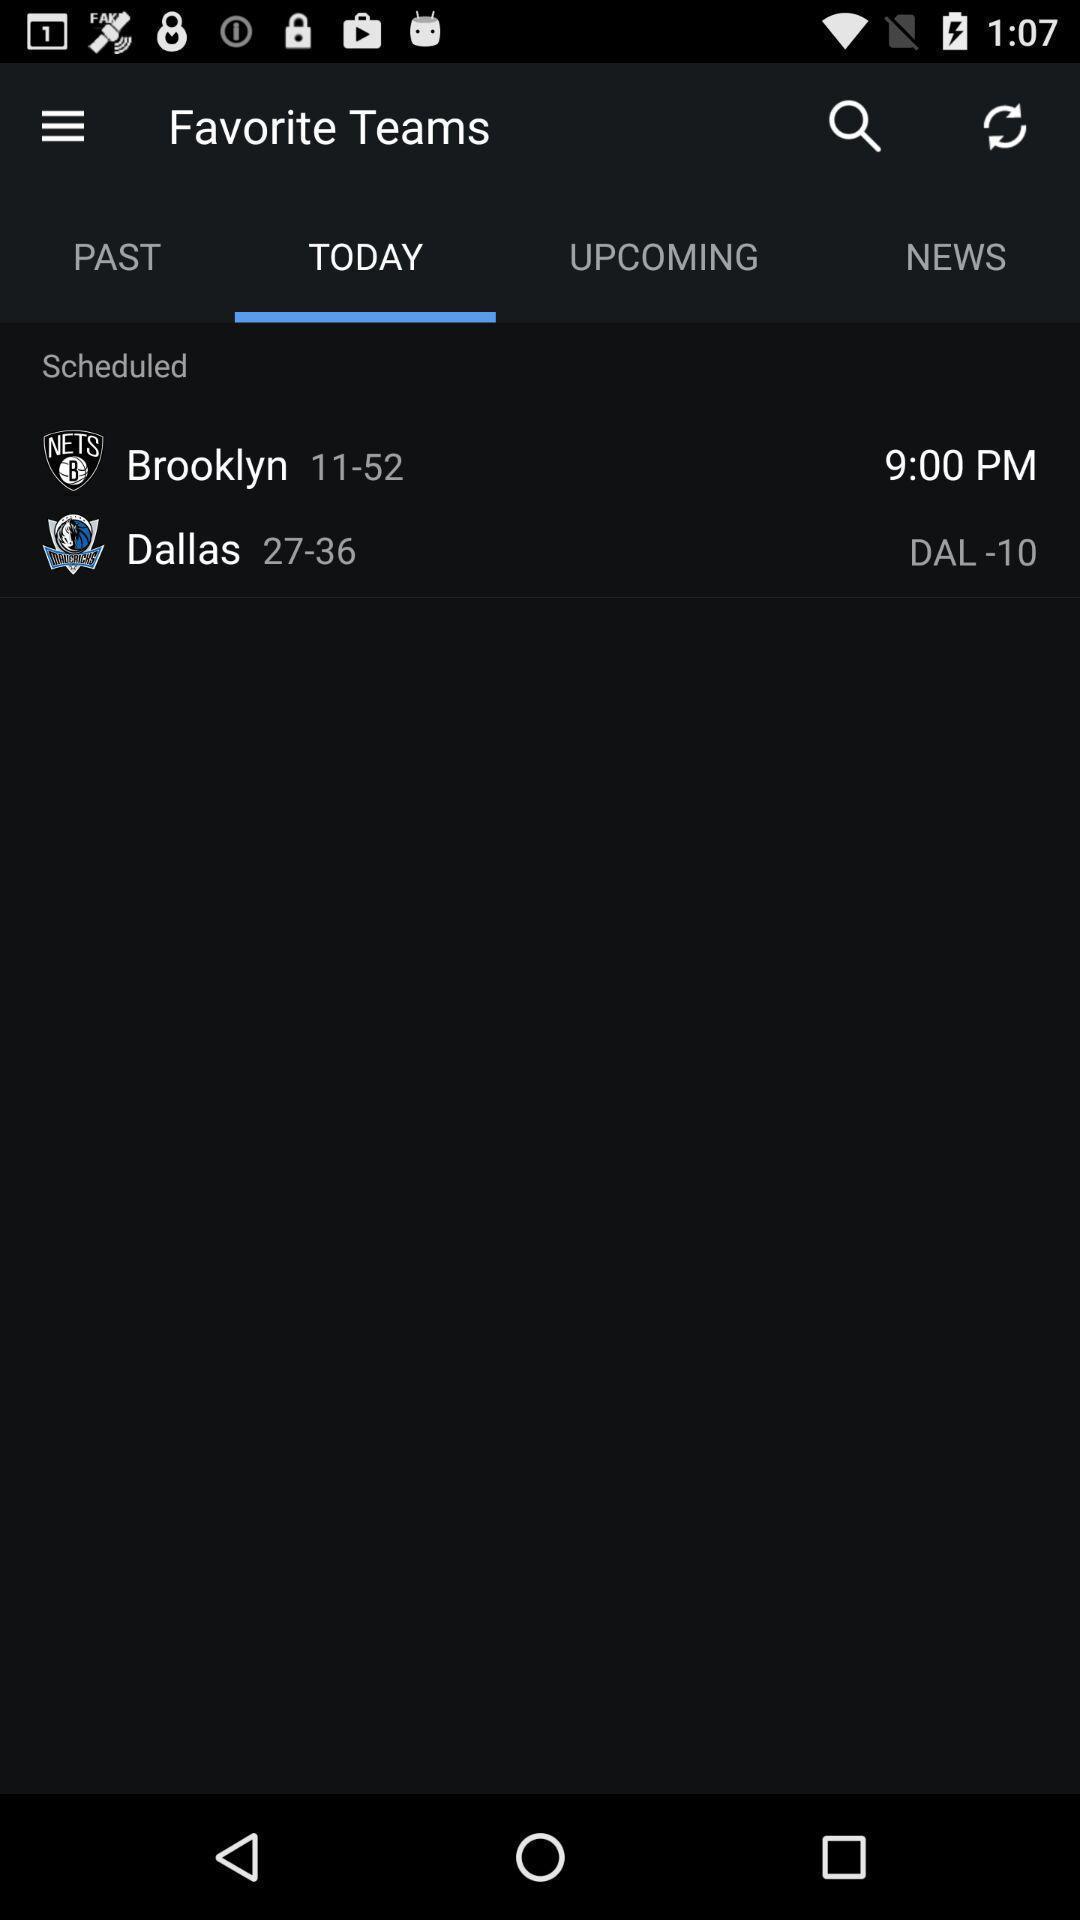Summarize the information in this screenshot. Screen showing scheduled of toady. 